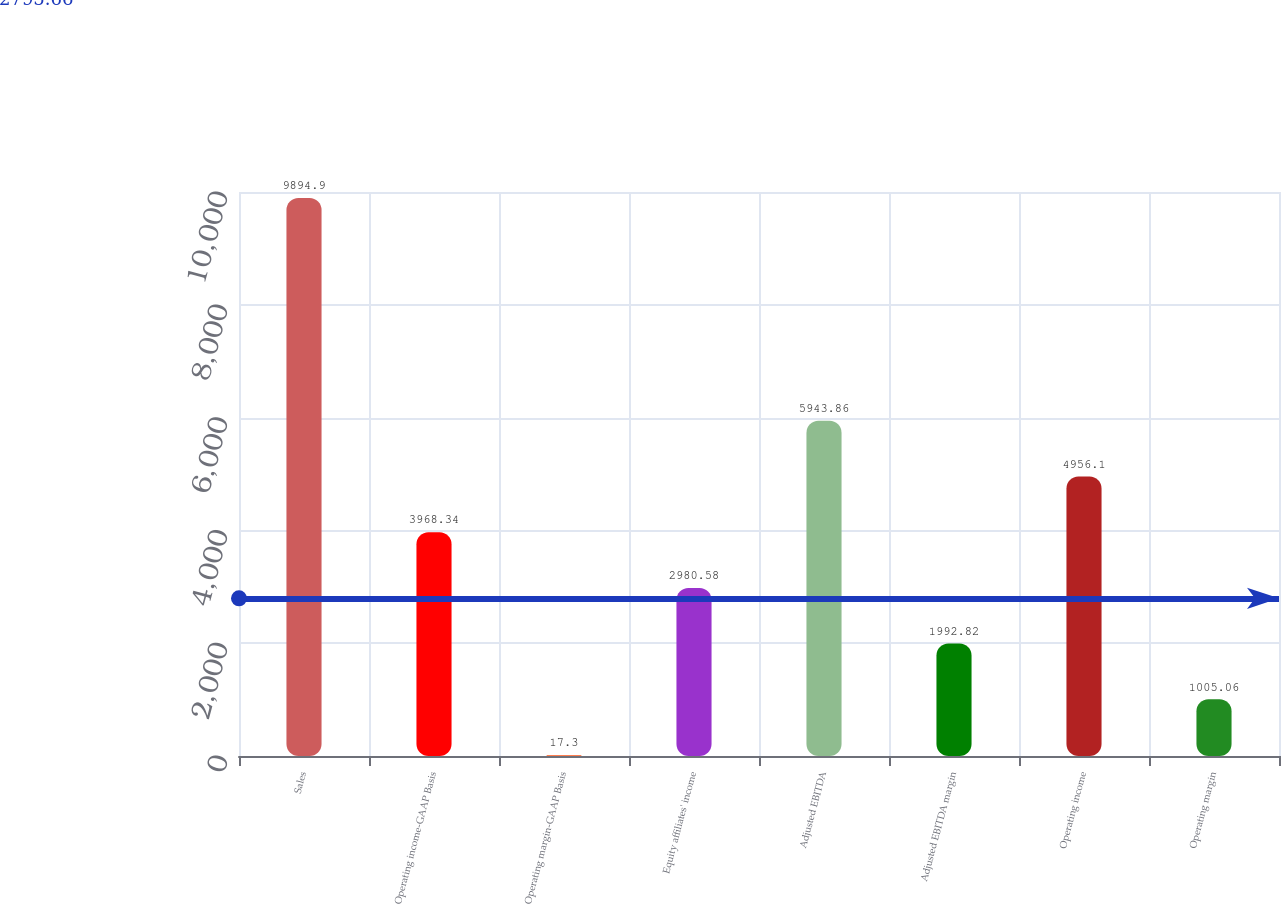Convert chart. <chart><loc_0><loc_0><loc_500><loc_500><bar_chart><fcel>Sales<fcel>Operating income-GAAP Basis<fcel>Operating margin-GAAP Basis<fcel>Equity affiliates' income<fcel>Adjusted EBITDA<fcel>Adjusted EBITDA margin<fcel>Operating income<fcel>Operating margin<nl><fcel>9894.9<fcel>3968.34<fcel>17.3<fcel>2980.58<fcel>5943.86<fcel>1992.82<fcel>4956.1<fcel>1005.06<nl></chart> 